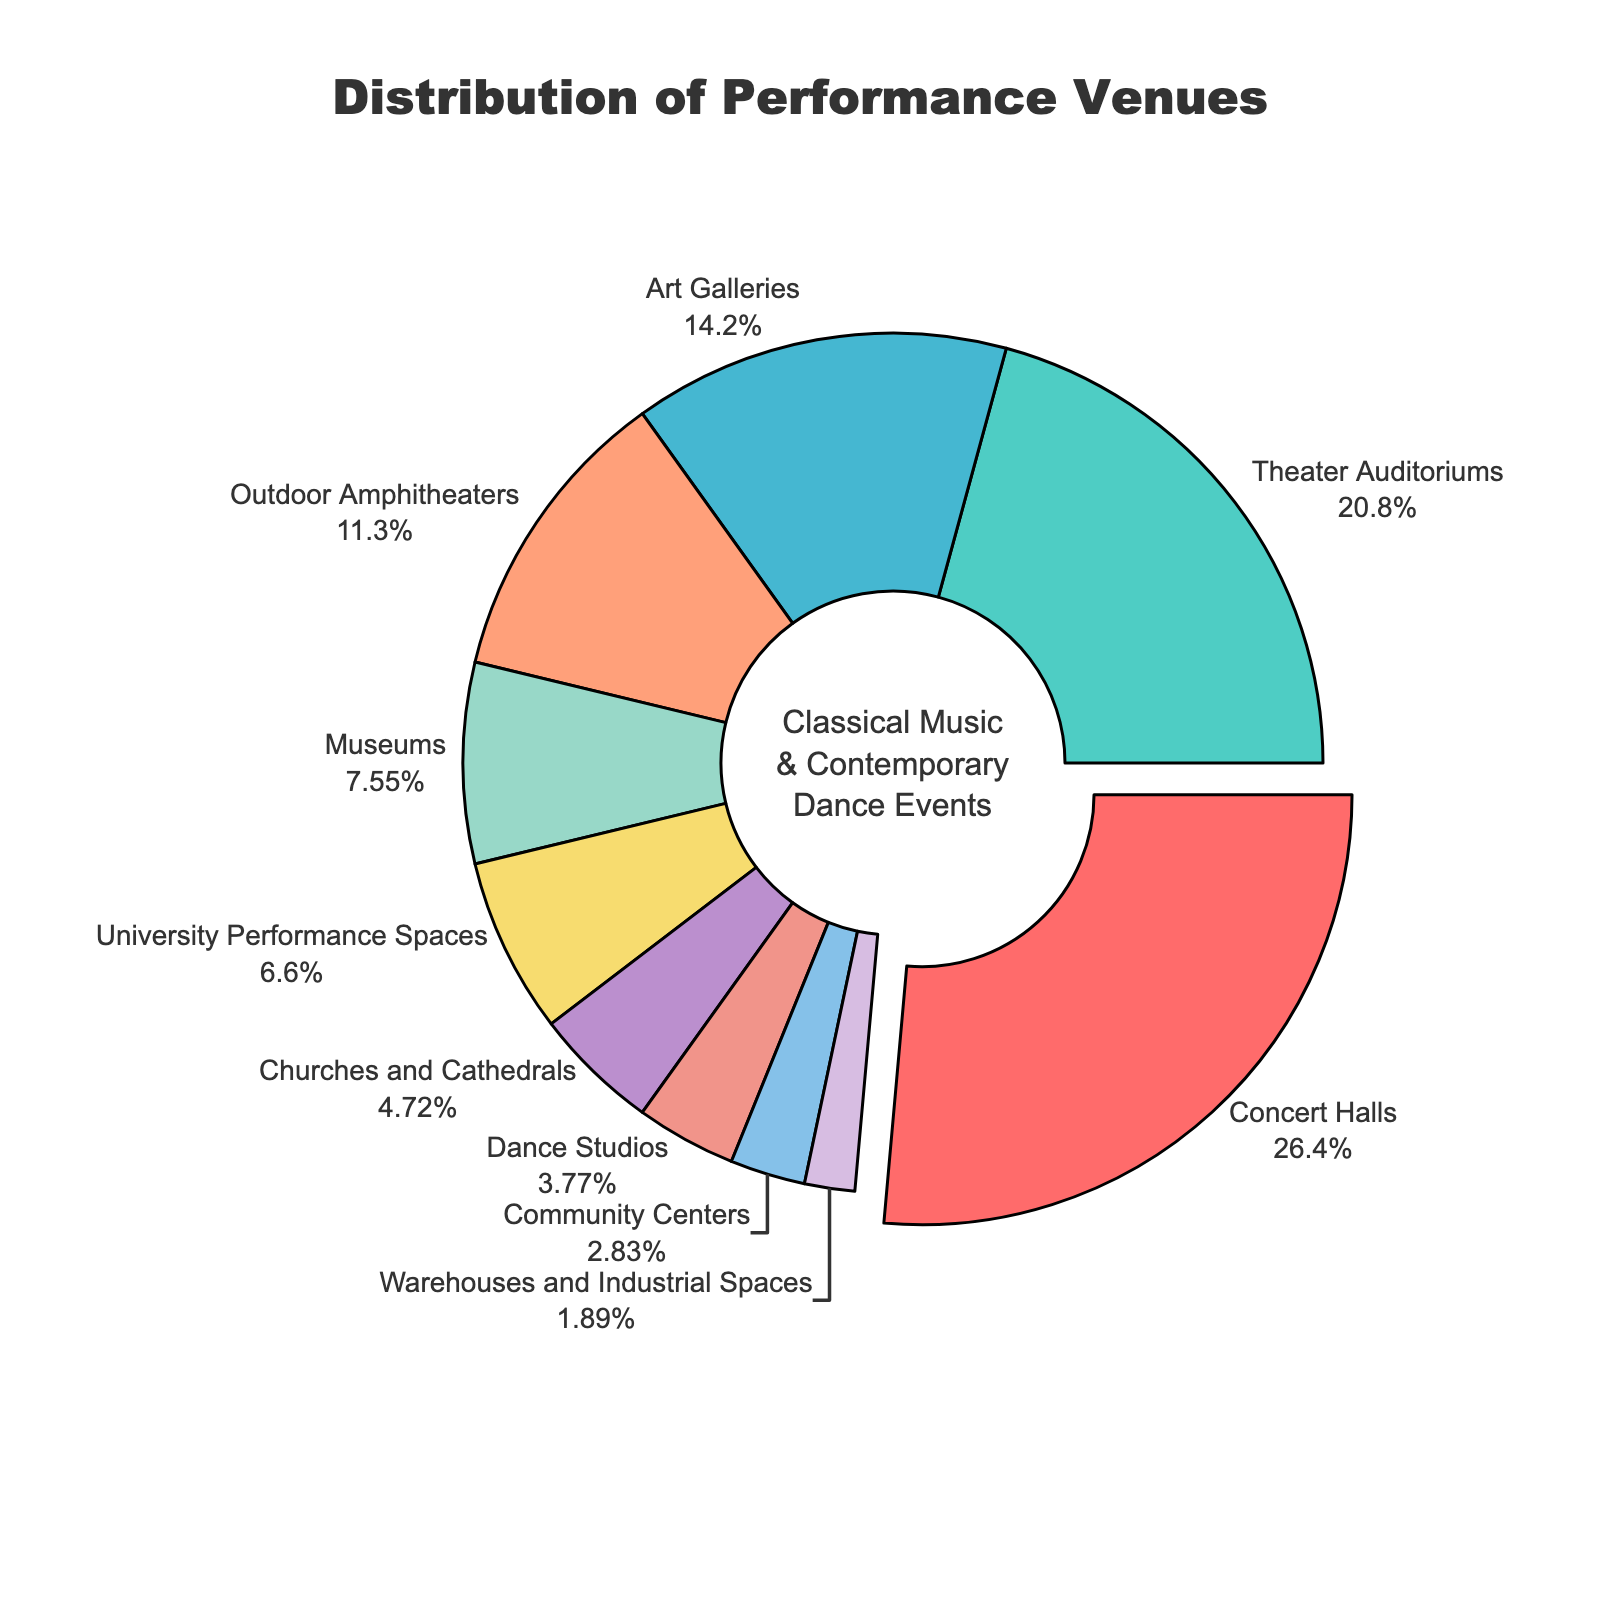Which venue type has the highest percentage? The largest segment, which is pulled out slightly, represents the Concert Halls. It shows this type has the highest percentage.
Answer: Concert Halls What is the combined percentage of Art Galleries and Museums? Art Galleries have a 15% share and Museums have 8%. Adding these together gives 23%.
Answer: 23% How does the percentage of Theater Auditoriums compare to Churches and Cathedrals? Theater Auditoriums have a 22% share, while Churches and Cathedrals have 5%. 22% is much greater than 5%.
Answer: Theater Auditoriums have a higher percentage than Churches and Cathedrals What percentage of venues are Outdoor Amphitheaters? The segment labeled Outdoor Amphitheaters shows a percentage of 12%.
Answer: 12% What are the venue types with the smallest and largest segments in the chart? The largest segment is Concert Halls with 28%, and the smallest segment is Warehouses and Industrial Spaces with 2%.
Answer: Warehouses and Industrial Spaces (smallest) and Concert Halls (largest) What is the percentage difference between University Performance Spaces and Dance Studios? University Performance Spaces have 7% and Dance Studios have 4%. Subtracting these gives 3%.
Answer: 3% Which venues have a share that is less than 5%? Dance Studios have 4%, Community Centers 3%, and Warehouses and Industrial Spaces 2%. All these are less than 5%.
Answer: Dance Studios, Community Centers, Warehouses and Industrial Spaces How many venue types have a percentage greater than 10%? Concert Halls (28%), Theater Auditoriums (22%), Art Galleries (15%), and Outdoor Amphitheaters (12%) all have percentages greater than 10%. That makes 4 venue types in total.
Answer: 4 What is the total percentage of all venues combined represented in the pie chart? The total percentage of all venues shown in the pie chart should be 100% as it represents the whole distribution.
Answer: 100% What fraction of the venues are either Museums or University Performance Spaces combined? Museums have 8% and University Performance Spaces have 7%, combining to 15%. 15% out of 100% is 15/100 or simplified to 3/20.
Answer: 3/20 